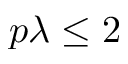Convert formula to latex. <formula><loc_0><loc_0><loc_500><loc_500>p \lambda \leq 2</formula> 